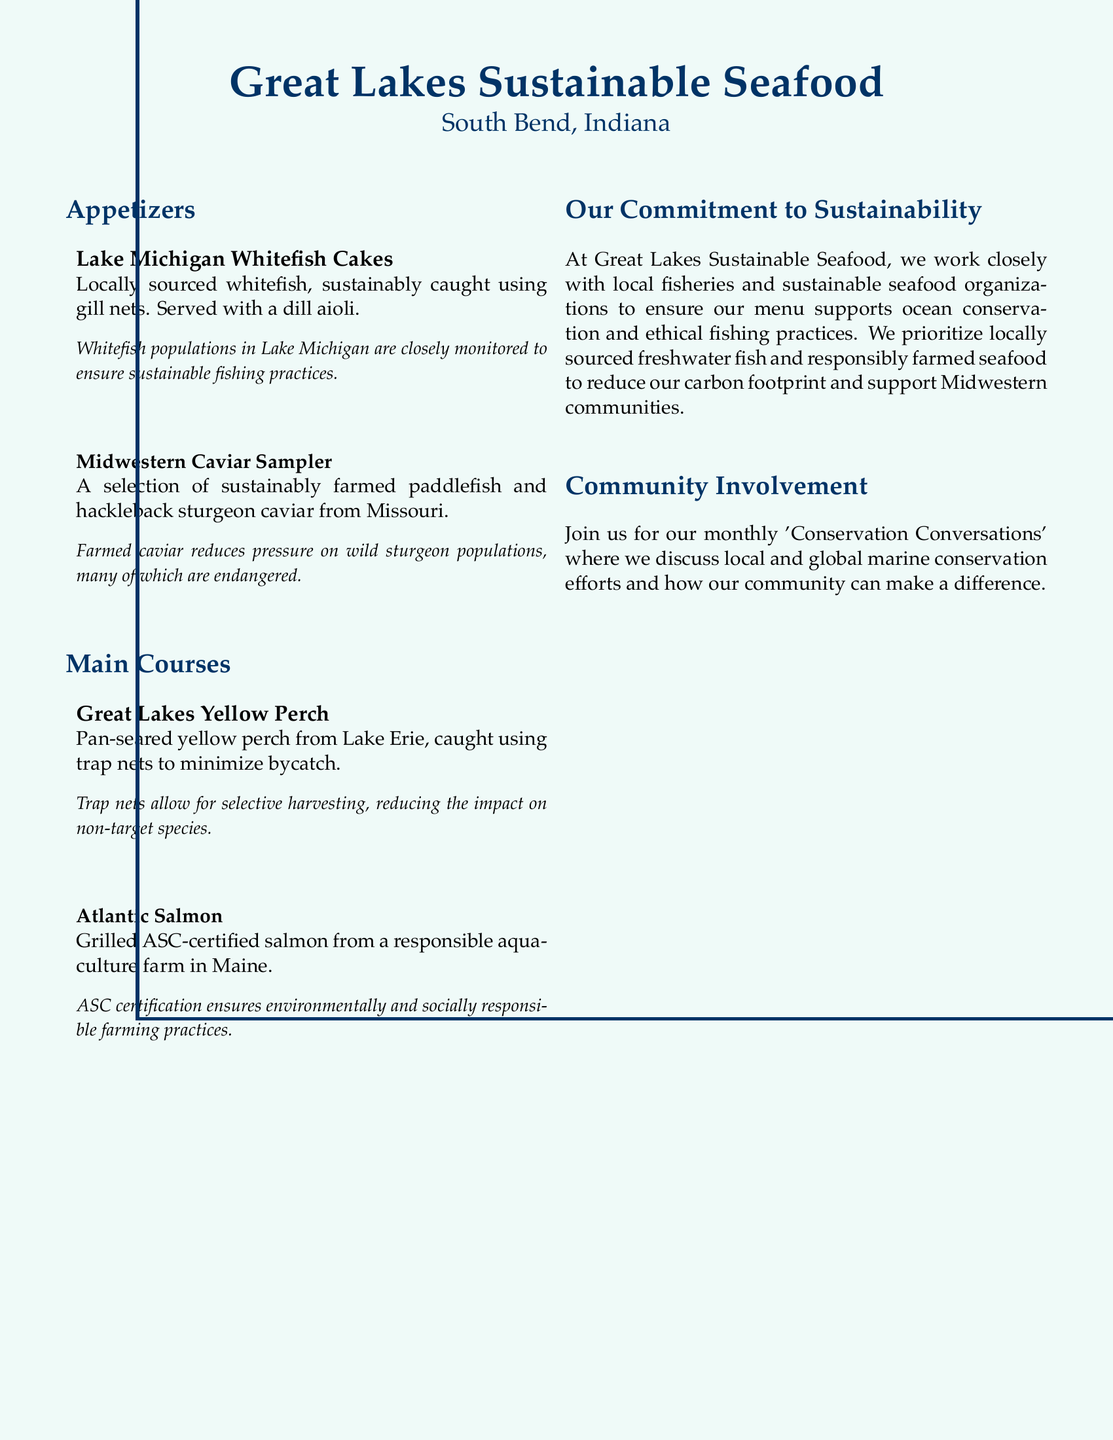What is the first appetizer listed? The first appetizer on the menu is the Lake Michigan Whitefish Cakes.
Answer: Lake Michigan Whitefish Cakes What fishing method is used for Great Lakes Yellow Perch? The Great Lakes Yellow Perch is caught using trap nets.
Answer: Trap nets What certification does the Atlantic Salmon have? The Atlantic Salmon is ASC-certified, which indicates responsible aquaculture farming.
Answer: ASC-certified Which community event is mentioned in the document? The document mentions 'Conservation Conversations', a monthly community event.
Answer: Conservation Conversations What is done to reduce bycatch in the fishing of the Great Lakes Yellow Perch? Trap nets are used to minimize bycatch during the fishing of Great Lakes Yellow Perch.
Answer: Minimize bycatch Which state is highlighted for responsibly farmed salmon? The responsibly farmed salmon is from Maine.
Answer: Maine What is the purpose of the monthly 'Conservation Conversations'? The purpose is to discuss local and global marine conservation efforts.
Answer: Discuss marine conservation efforts How does the restaurant support the local community? The restaurant supports Midwestern communities by prioritizing locally sourced fish.
Answer: Prioritizing locally sourced fish 